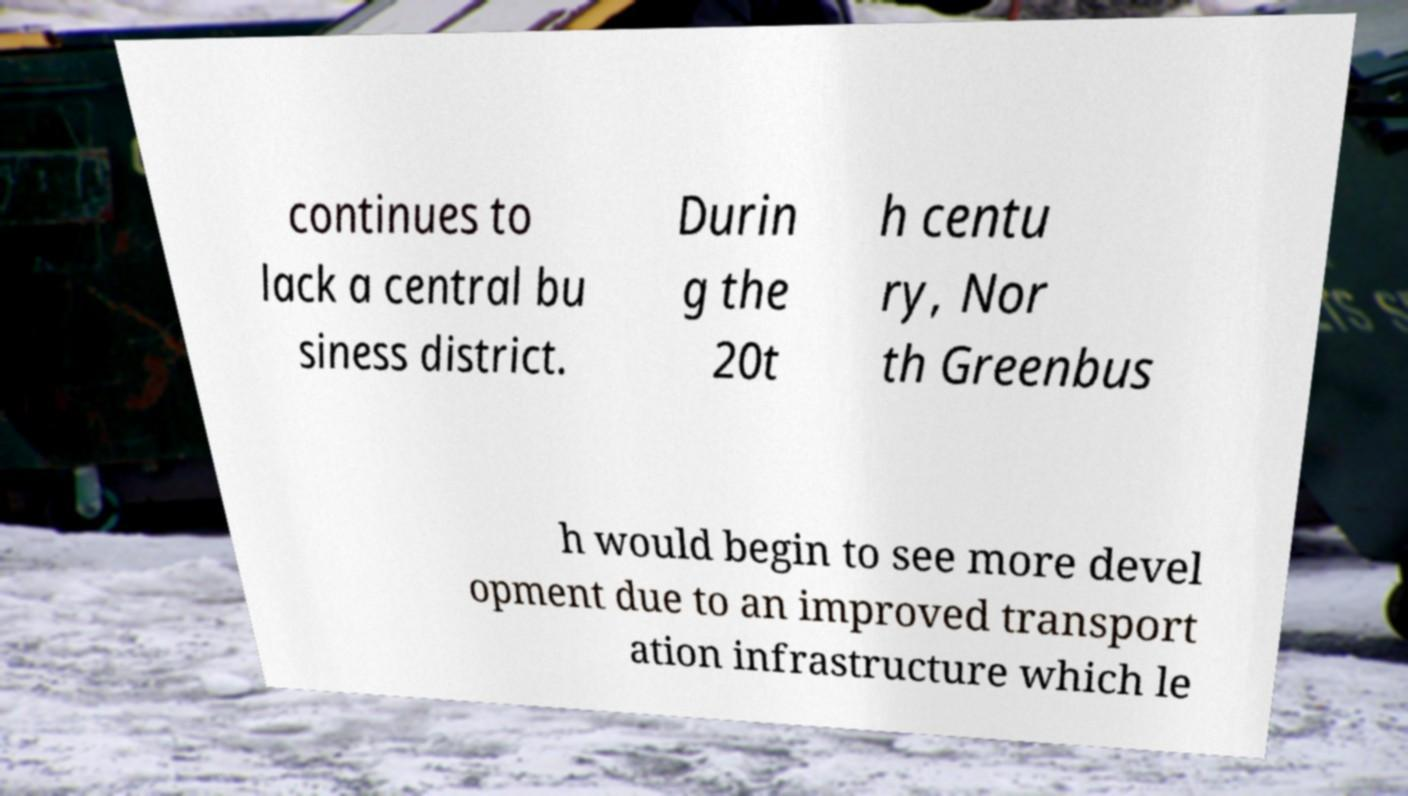I need the written content from this picture converted into text. Can you do that? continues to lack a central bu siness district. Durin g the 20t h centu ry, Nor th Greenbus h would begin to see more devel opment due to an improved transport ation infrastructure which le 